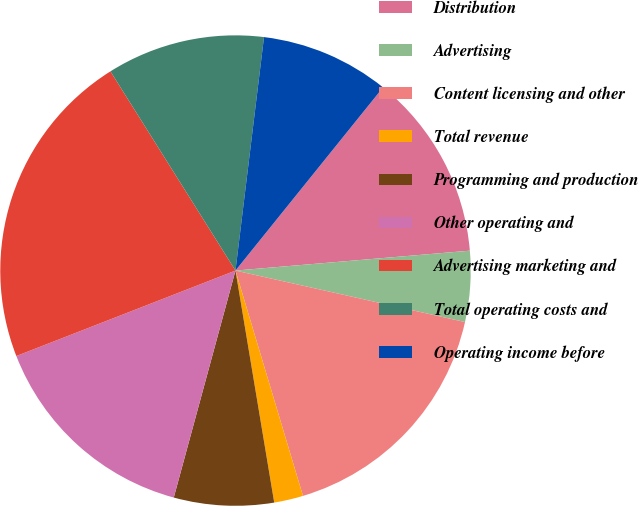Convert chart. <chart><loc_0><loc_0><loc_500><loc_500><pie_chart><fcel>Distribution<fcel>Advertising<fcel>Content licensing and other<fcel>Total revenue<fcel>Programming and production<fcel>Other operating and<fcel>Advertising marketing and<fcel>Total operating costs and<fcel>Operating income before<nl><fcel>12.86%<fcel>4.86%<fcel>16.86%<fcel>2.0%<fcel>6.86%<fcel>14.86%<fcel>22.0%<fcel>10.86%<fcel>8.86%<nl></chart> 